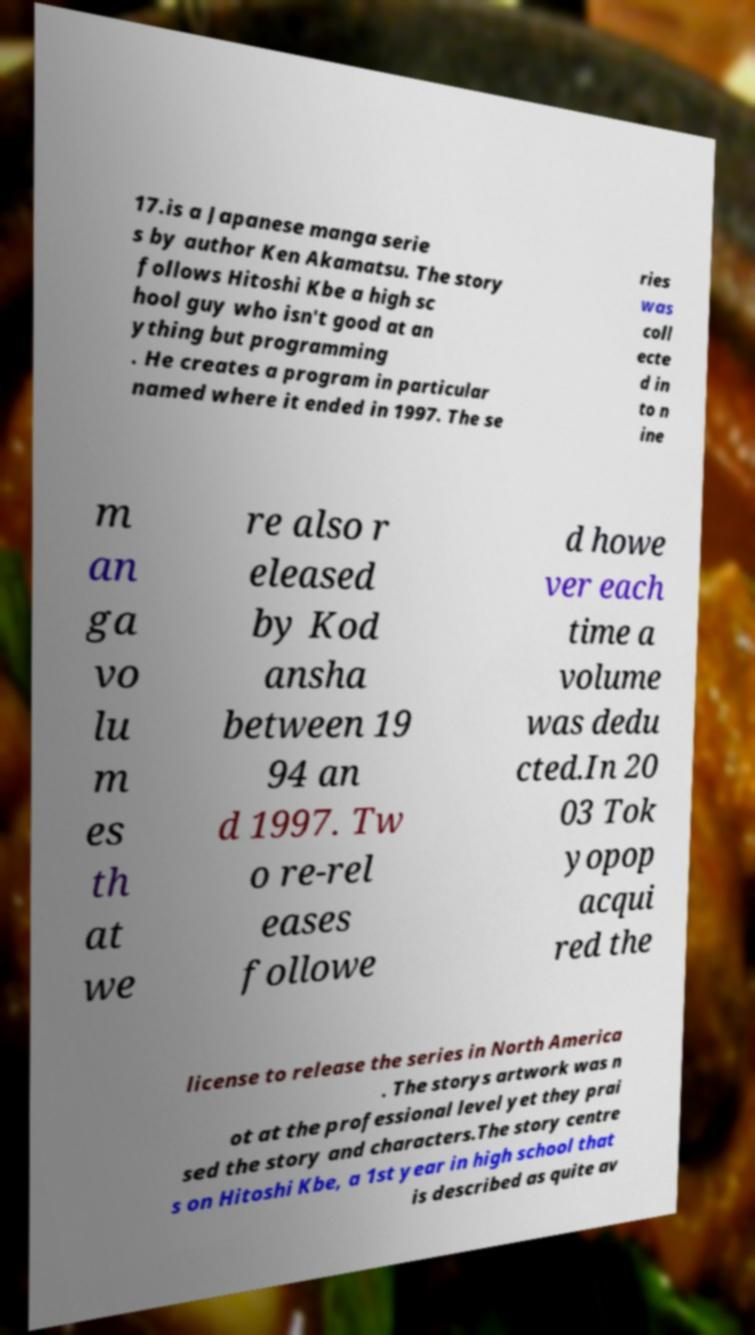Can you accurately transcribe the text from the provided image for me? 17.is a Japanese manga serie s by author Ken Akamatsu. The story follows Hitoshi Kbe a high sc hool guy who isn't good at an ything but programming . He creates a program in particular named where it ended in 1997. The se ries was coll ecte d in to n ine m an ga vo lu m es th at we re also r eleased by Kod ansha between 19 94 an d 1997. Tw o re-rel eases followe d howe ver each time a volume was dedu cted.In 20 03 Tok yopop acqui red the license to release the series in North America . The storys artwork was n ot at the professional level yet they prai sed the story and characters.The story centre s on Hitoshi Kbe, a 1st year in high school that is described as quite av 